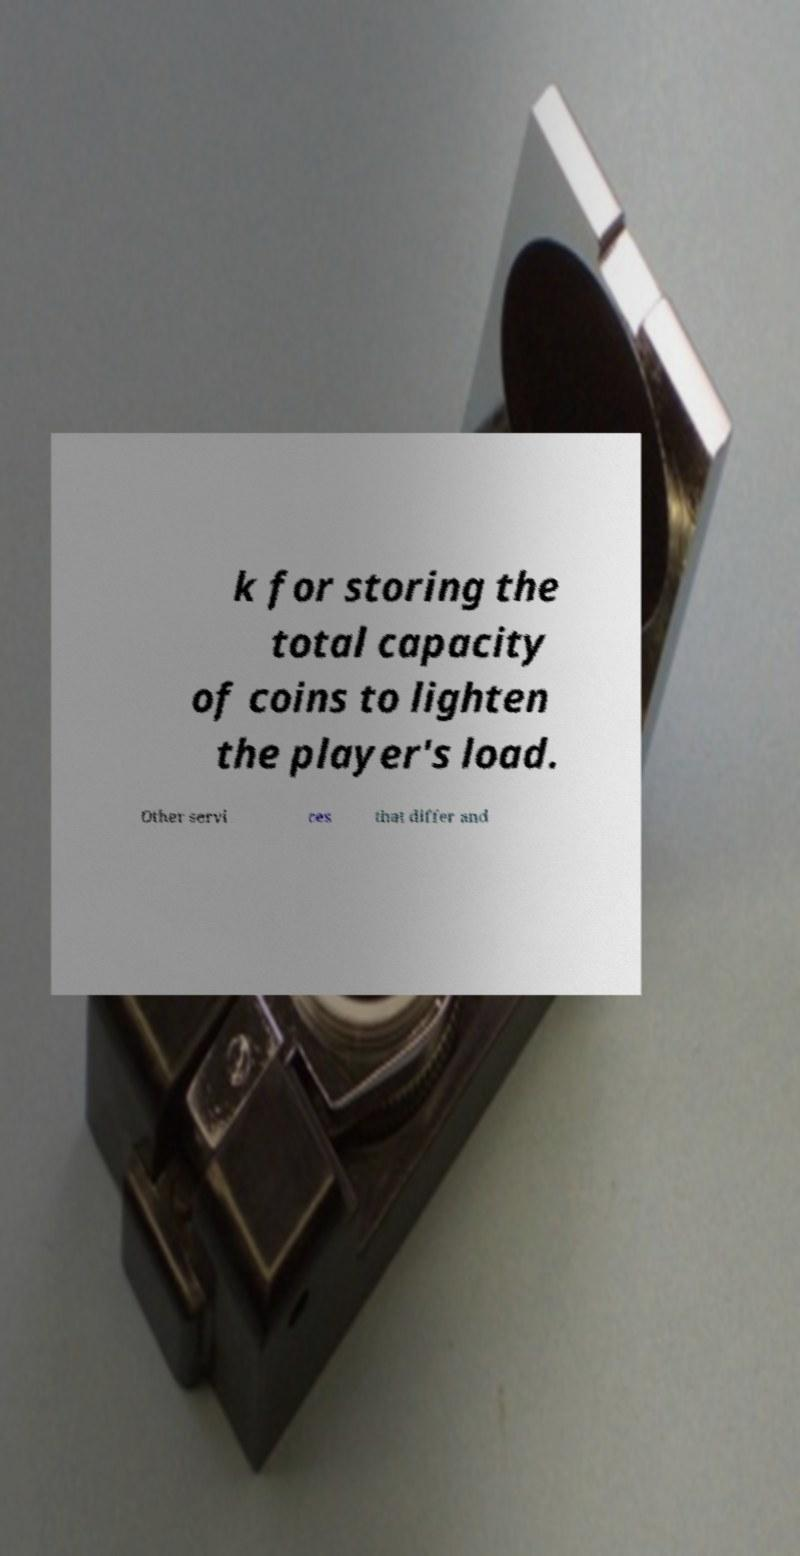Can you accurately transcribe the text from the provided image for me? k for storing the total capacity of coins to lighten the player's load. Other servi ces that differ and 